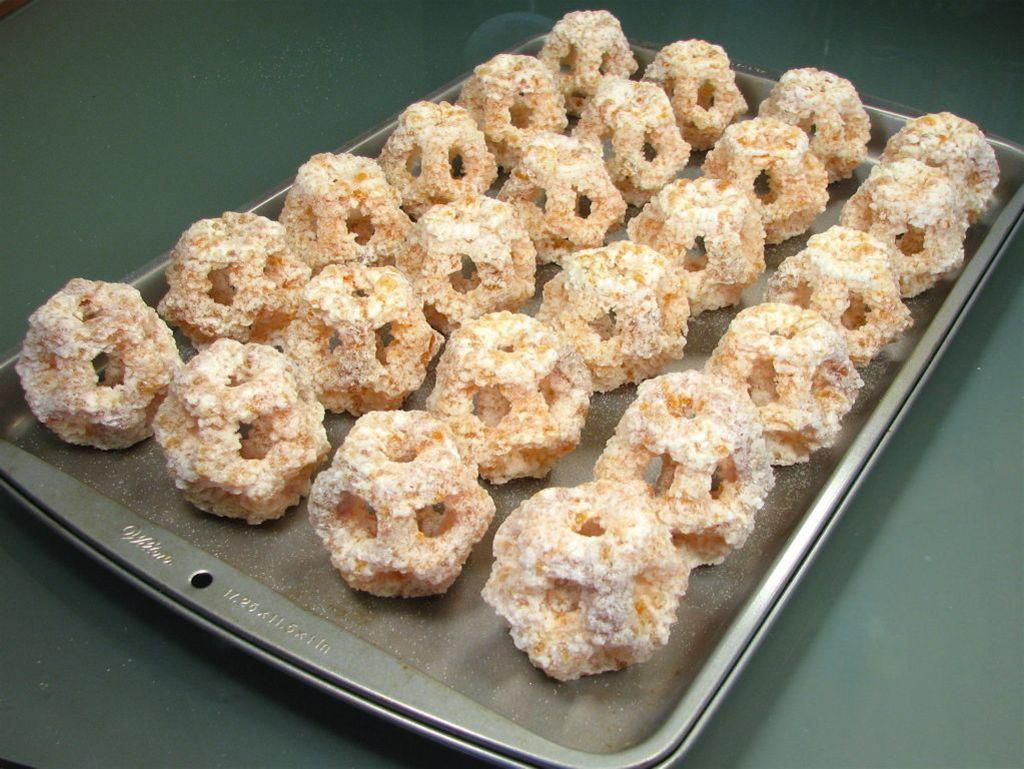What type of food can be seen in the image? The food in the image is in brown color. How is the food arranged or presented? The food is in a tray. What is the color of the surface on which the tray is placed? The tray is on a gray color surface. Is there any blood visible on the food in the image? No, there is no blood visible on the food in the image. Is there any indication that a spy is present in the image? No, there is no indication of a spy or any related activity in the image. 